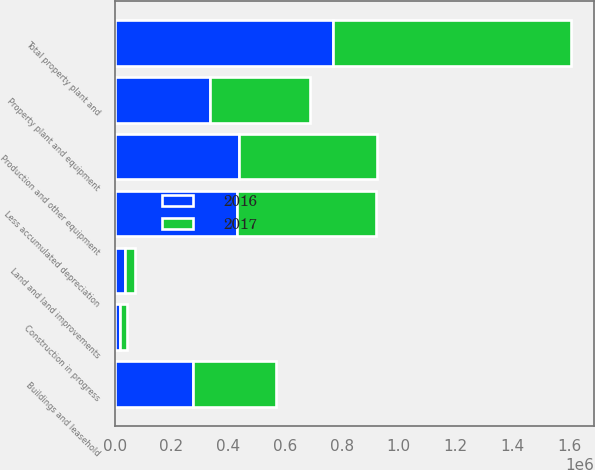Convert chart to OTSL. <chart><loc_0><loc_0><loc_500><loc_500><stacked_bar_chart><ecel><fcel>Land and land improvements<fcel>Buildings and leasehold<fcel>Production and other equipment<fcel>Construction in progress<fcel>Total property plant and<fcel>Less accumulated depreciation<fcel>Property plant and equipment<nl><fcel>2017<fcel>37525<fcel>294219<fcel>484475<fcel>22140<fcel>838359<fcel>489081<fcel>349278<nl><fcel>2016<fcel>35720<fcel>274021<fcel>438604<fcel>20204<fcel>768549<fcel>431431<fcel>337118<nl></chart> 